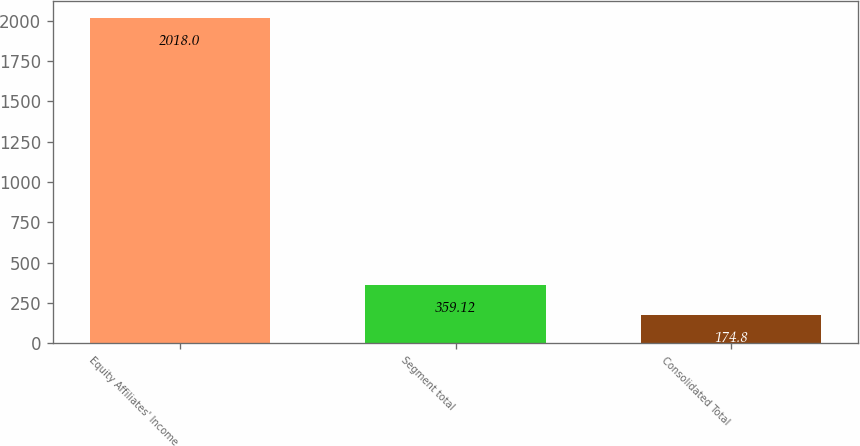Convert chart. <chart><loc_0><loc_0><loc_500><loc_500><bar_chart><fcel>Equity Affiliates' Income<fcel>Segment total<fcel>Consolidated Total<nl><fcel>2018<fcel>359.12<fcel>174.8<nl></chart> 